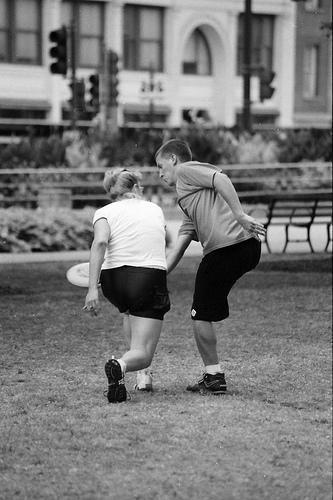How many people in white shirts are there?
Give a very brief answer. 1. 